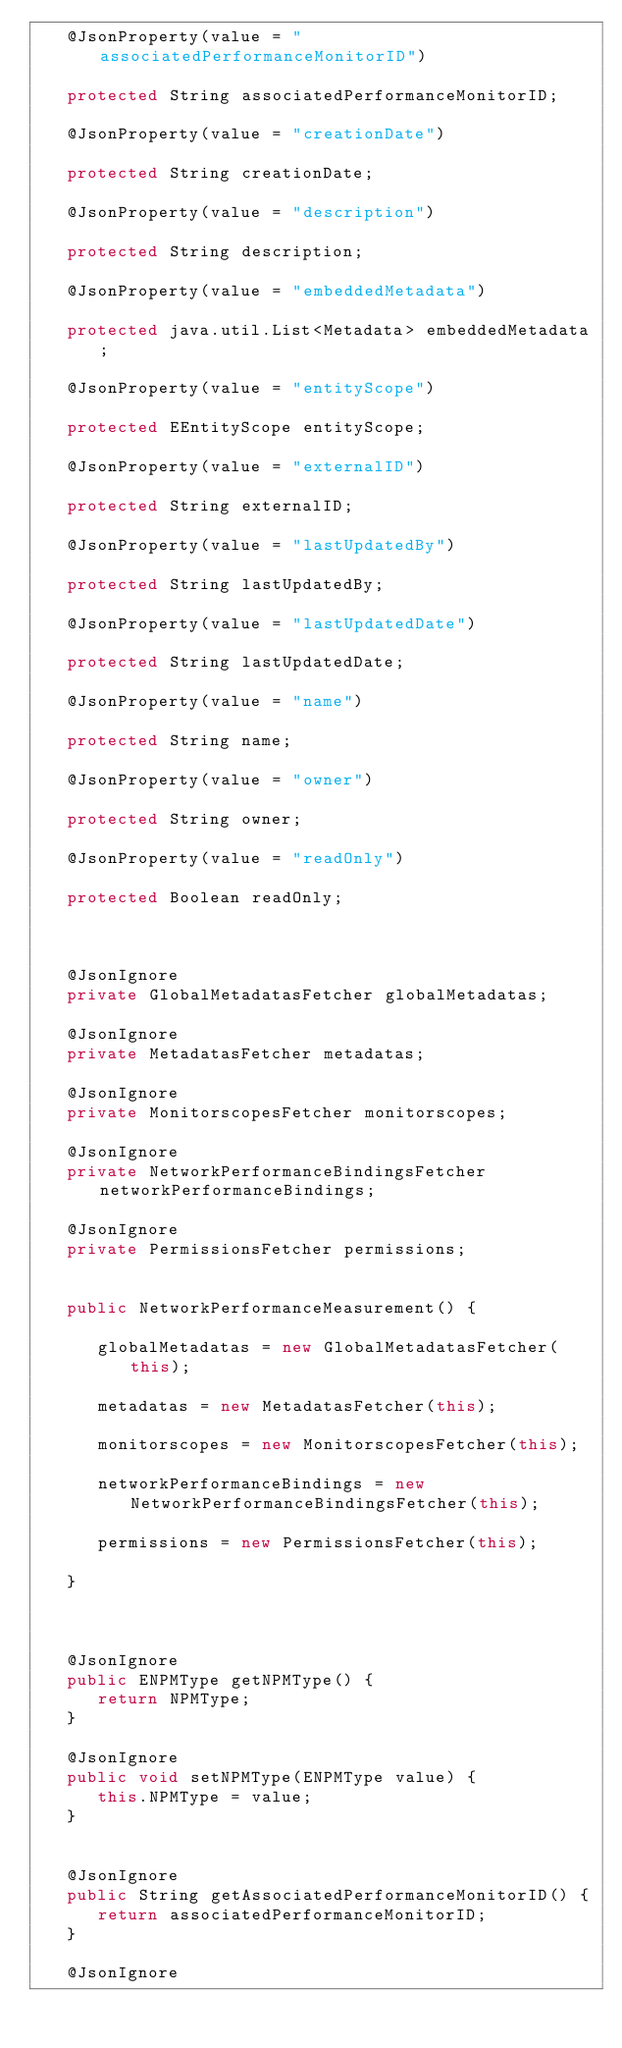Convert code to text. <code><loc_0><loc_0><loc_500><loc_500><_Java_>   @JsonProperty(value = "associatedPerformanceMonitorID")
   
   protected String associatedPerformanceMonitorID;
   
   @JsonProperty(value = "creationDate")
   
   protected String creationDate;
   
   @JsonProperty(value = "description")
   
   protected String description;
   
   @JsonProperty(value = "embeddedMetadata")
   
   protected java.util.List<Metadata> embeddedMetadata;
   
   @JsonProperty(value = "entityScope")
   
   protected EEntityScope entityScope;
   
   @JsonProperty(value = "externalID")
   
   protected String externalID;
   
   @JsonProperty(value = "lastUpdatedBy")
   
   protected String lastUpdatedBy;
   
   @JsonProperty(value = "lastUpdatedDate")
   
   protected String lastUpdatedDate;
   
   @JsonProperty(value = "name")
   
   protected String name;
   
   @JsonProperty(value = "owner")
   
   protected String owner;
   
   @JsonProperty(value = "readOnly")
   
   protected Boolean readOnly;
   

   
   @JsonIgnore
   private GlobalMetadatasFetcher globalMetadatas;
   
   @JsonIgnore
   private MetadatasFetcher metadatas;
   
   @JsonIgnore
   private MonitorscopesFetcher monitorscopes;
   
   @JsonIgnore
   private NetworkPerformanceBindingsFetcher networkPerformanceBindings;
   
   @JsonIgnore
   private PermissionsFetcher permissions;
   

   public NetworkPerformanceMeasurement() {
      
      globalMetadatas = new GlobalMetadatasFetcher(this);
      
      metadatas = new MetadatasFetcher(this);
      
      monitorscopes = new MonitorscopesFetcher(this);
      
      networkPerformanceBindings = new NetworkPerformanceBindingsFetcher(this);
      
      permissions = new PermissionsFetcher(this);
      
   }

   
   
   @JsonIgnore
   public ENPMType getNPMType() {
      return NPMType;
   }

   @JsonIgnore
   public void setNPMType(ENPMType value) { 
      this.NPMType = value;
   }
   
   
   @JsonIgnore
   public String getAssociatedPerformanceMonitorID() {
      return associatedPerformanceMonitorID;
   }

   @JsonIgnore</code> 